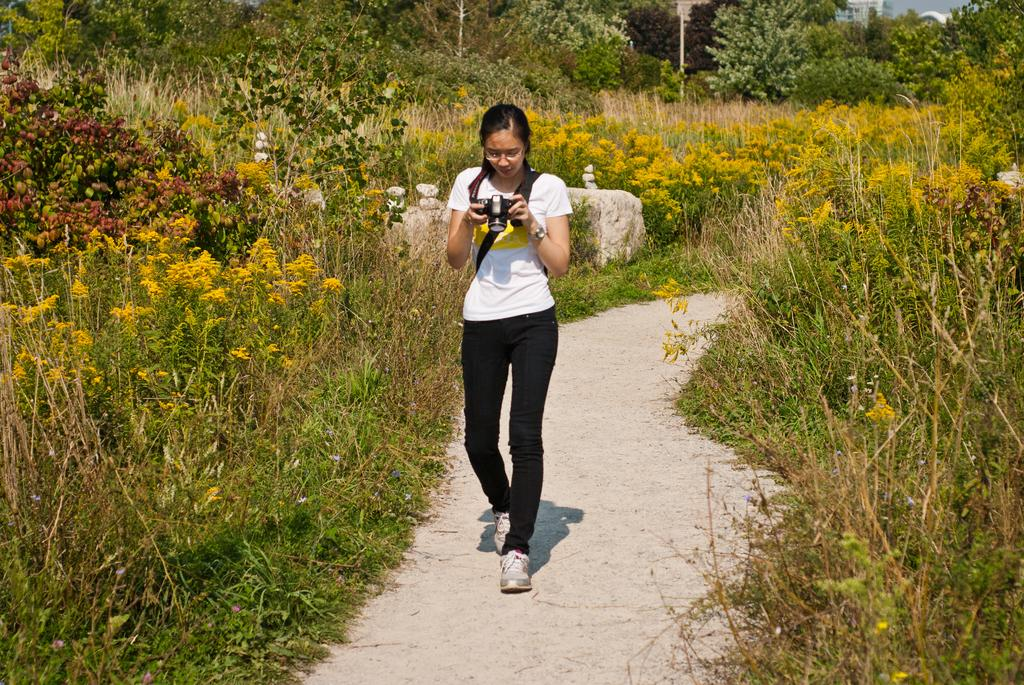Who is the main subject in the image? There is a girl in the image. What is the girl doing in the image? The girl is walking in the image. What is the girl holding in her hands? The girl is holding a camera in her hands. What can be seen in the background of the image? There are small trees in the background of the image on both sides. How many apples are hanging from the tree in the image? There is no tree with apples present in the image; there are only small trees in the background. What type of wrench is the girl using to take pictures in the image? The girl is not using a wrench in the image; she is holding a camera to take pictures. 